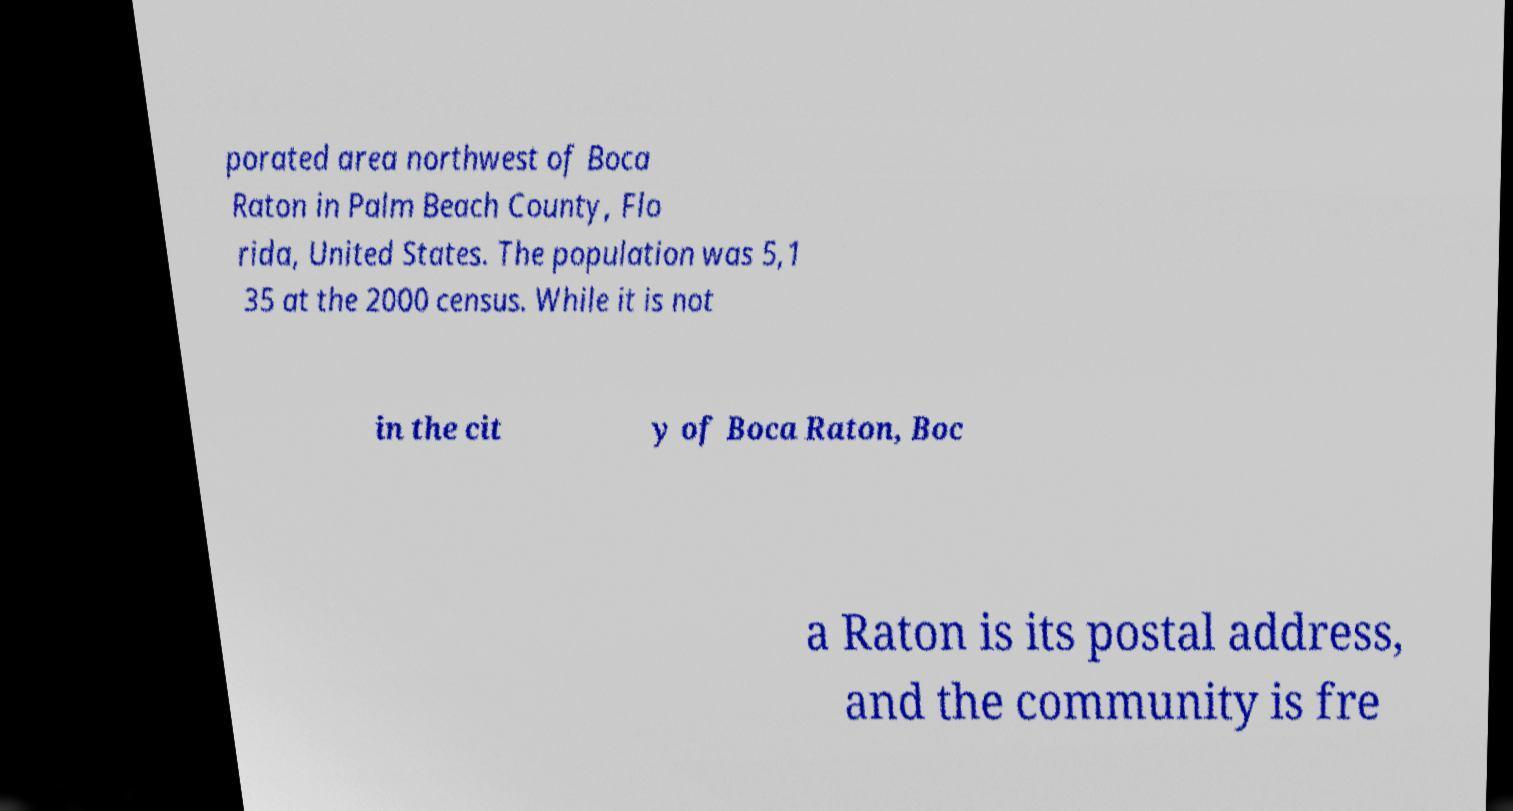For documentation purposes, I need the text within this image transcribed. Could you provide that? porated area northwest of Boca Raton in Palm Beach County, Flo rida, United States. The population was 5,1 35 at the 2000 census. While it is not in the cit y of Boca Raton, Boc a Raton is its postal address, and the community is fre 